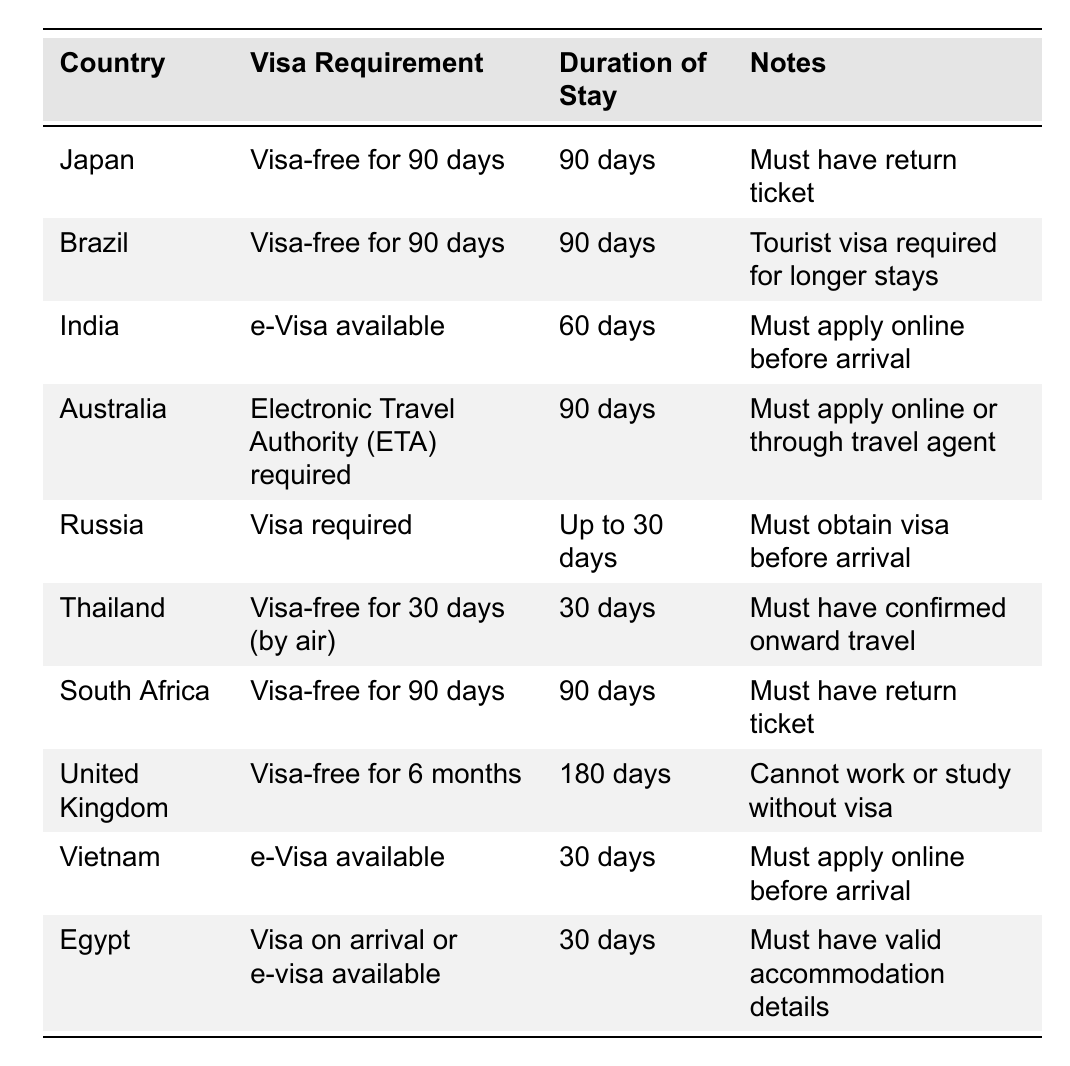What is the visa requirement for Brazil? The table states that Brazil requires a visa-free entry for 90 days for US passport holders.
Answer: Visa-free for 90 days How long can a US passport holder stay in Japan without a visa? According to the table, a US passport holder can stay in Japan for 90 days without a visa.
Answer: 90 days Is there a visa on arrival option for Egypt? The table indicates that Egypt offers either a visa on arrival or an e-visa for US passport holders.
Answer: Yes How long can you stay in Thailand without a visa? The table lists Thailand's duration of stay as 30 days for US passport holders arriving by air.
Answer: 30 days Do you need to apply for a visa before going to India? The table specifies that an e-Visa is available for India, which must be applied for online before arrival.
Answer: Yes Which country allows the longest visa-free stay for US passport holders? By comparing the entries, the United Kingdom allows for a visa-free stay of 180 days, which is the longest duration listed.
Answer: United Kingdom (180 days) What must be provided for entry into Egypt? The table notes that you must have valid accommodation details to enter Egypt, either with a visa on arrival or an e-visa.
Answer: Valid accommodation details Can a tourist work in the United Kingdom with a visa-free entry? The table states that tourists cannot work or study in the United Kingdom without a visa.
Answer: No Which countries require an online application before arrival? The table lists India and Vietnam as countries that require an online application for their e-Visas before arrival.
Answer: India and Vietnam If a US passport holder plans to travel to Russia and Thailand, how many days can they stay in total without needing a visa? The table specifies that in Russia, the stay is up to 30 days and in Thailand, it's 30 days by air. Thus, together they can stay for 30 + 30 = 60 days without a visa.
Answer: 60 days 